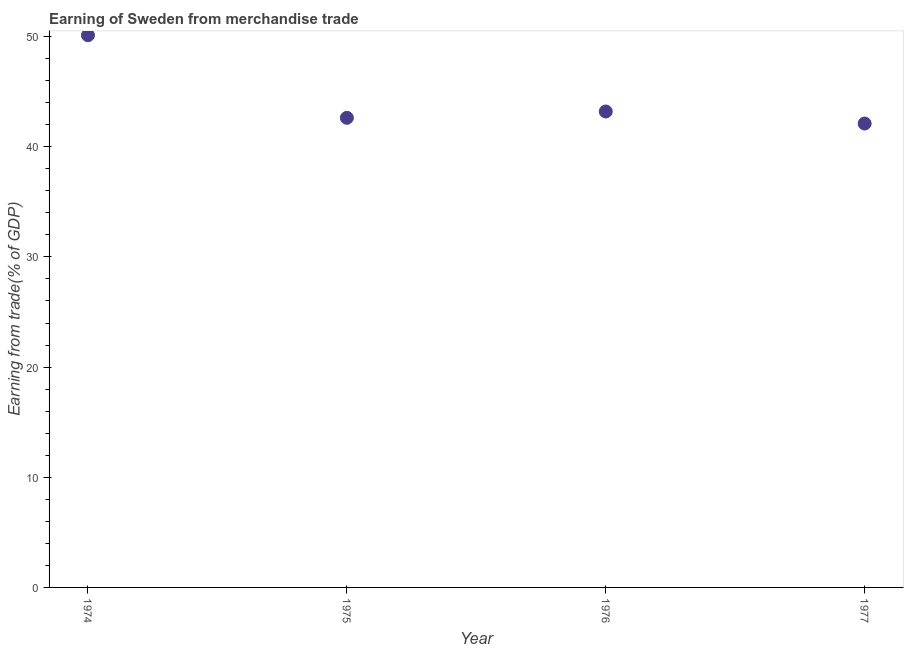What is the earning from merchandise trade in 1977?
Offer a very short reply. 42.11. Across all years, what is the maximum earning from merchandise trade?
Your answer should be compact. 50.12. Across all years, what is the minimum earning from merchandise trade?
Give a very brief answer. 42.11. In which year was the earning from merchandise trade maximum?
Offer a terse response. 1974. In which year was the earning from merchandise trade minimum?
Provide a short and direct response. 1977. What is the sum of the earning from merchandise trade?
Offer a terse response. 178.06. What is the difference between the earning from merchandise trade in 1975 and 1976?
Your answer should be very brief. -0.58. What is the average earning from merchandise trade per year?
Offer a terse response. 44.52. What is the median earning from merchandise trade?
Give a very brief answer. 42.92. What is the ratio of the earning from merchandise trade in 1975 to that in 1977?
Offer a very short reply. 1.01. Is the earning from merchandise trade in 1974 less than that in 1976?
Ensure brevity in your answer.  No. What is the difference between the highest and the second highest earning from merchandise trade?
Your response must be concise. 6.92. What is the difference between the highest and the lowest earning from merchandise trade?
Your response must be concise. 8.01. In how many years, is the earning from merchandise trade greater than the average earning from merchandise trade taken over all years?
Keep it short and to the point. 1. Does the earning from merchandise trade monotonically increase over the years?
Your response must be concise. No. How many years are there in the graph?
Your response must be concise. 4. Are the values on the major ticks of Y-axis written in scientific E-notation?
Provide a short and direct response. No. What is the title of the graph?
Provide a short and direct response. Earning of Sweden from merchandise trade. What is the label or title of the Y-axis?
Provide a succinct answer. Earning from trade(% of GDP). What is the Earning from trade(% of GDP) in 1974?
Give a very brief answer. 50.12. What is the Earning from trade(% of GDP) in 1975?
Your response must be concise. 42.63. What is the Earning from trade(% of GDP) in 1976?
Provide a succinct answer. 43.2. What is the Earning from trade(% of GDP) in 1977?
Your answer should be very brief. 42.11. What is the difference between the Earning from trade(% of GDP) in 1974 and 1975?
Ensure brevity in your answer.  7.5. What is the difference between the Earning from trade(% of GDP) in 1974 and 1976?
Ensure brevity in your answer.  6.92. What is the difference between the Earning from trade(% of GDP) in 1974 and 1977?
Your response must be concise. 8.01. What is the difference between the Earning from trade(% of GDP) in 1975 and 1976?
Provide a short and direct response. -0.58. What is the difference between the Earning from trade(% of GDP) in 1975 and 1977?
Offer a very short reply. 0.52. What is the difference between the Earning from trade(% of GDP) in 1976 and 1977?
Offer a terse response. 1.09. What is the ratio of the Earning from trade(% of GDP) in 1974 to that in 1975?
Offer a very short reply. 1.18. What is the ratio of the Earning from trade(% of GDP) in 1974 to that in 1976?
Offer a terse response. 1.16. What is the ratio of the Earning from trade(% of GDP) in 1974 to that in 1977?
Provide a short and direct response. 1.19. What is the ratio of the Earning from trade(% of GDP) in 1975 to that in 1976?
Offer a terse response. 0.99. What is the ratio of the Earning from trade(% of GDP) in 1976 to that in 1977?
Provide a short and direct response. 1.03. 